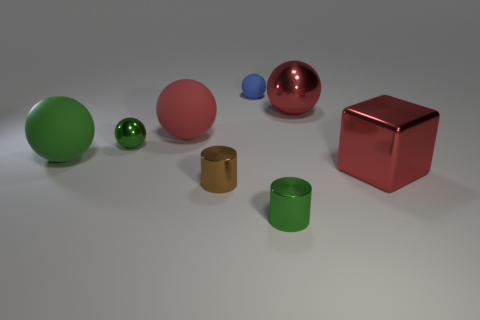There is a shiny ball in front of the big red metal sphere; is its color the same as the rubber object that is on the right side of the red rubber object?
Your answer should be very brief. No. What material is the green object that is in front of the large shiny thing in front of the green metallic object behind the big block?
Give a very brief answer. Metal. Is the number of large green balls greater than the number of purple cylinders?
Give a very brief answer. Yes. Is there any other thing that has the same color as the big shiny cube?
Provide a succinct answer. Yes. What is the size of the brown cylinder that is made of the same material as the tiny green cylinder?
Your answer should be compact. Small. What is the material of the blue thing?
Give a very brief answer. Rubber. What number of matte balls have the same size as the brown shiny cylinder?
Give a very brief answer. 1. What shape is the tiny shiny thing that is the same color as the tiny metal ball?
Provide a short and direct response. Cylinder. Is there another big blue thing that has the same shape as the blue matte thing?
Make the answer very short. No. What is the color of the shiny object that is the same size as the red metallic cube?
Provide a short and direct response. Red. 